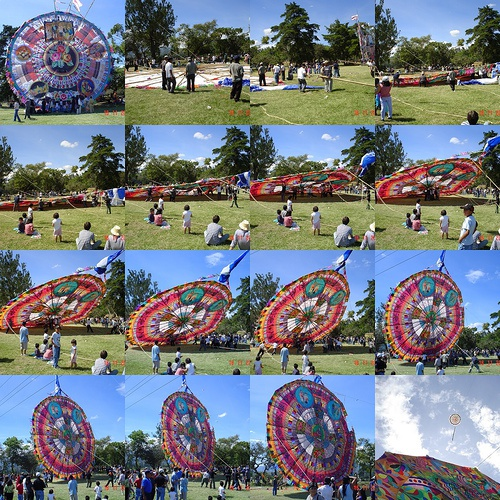Describe the objects in this image and their specific colors. I can see people in lightblue, black, olive, gray, and darkgray tones, kite in lightblue, gray, navy, and darkgray tones, kite in lightblue, gray, purple, navy, and maroon tones, kite in lightblue, gray, maroon, darkgray, and brown tones, and kite in lightblue, maroon, gray, darkgray, and brown tones in this image. 